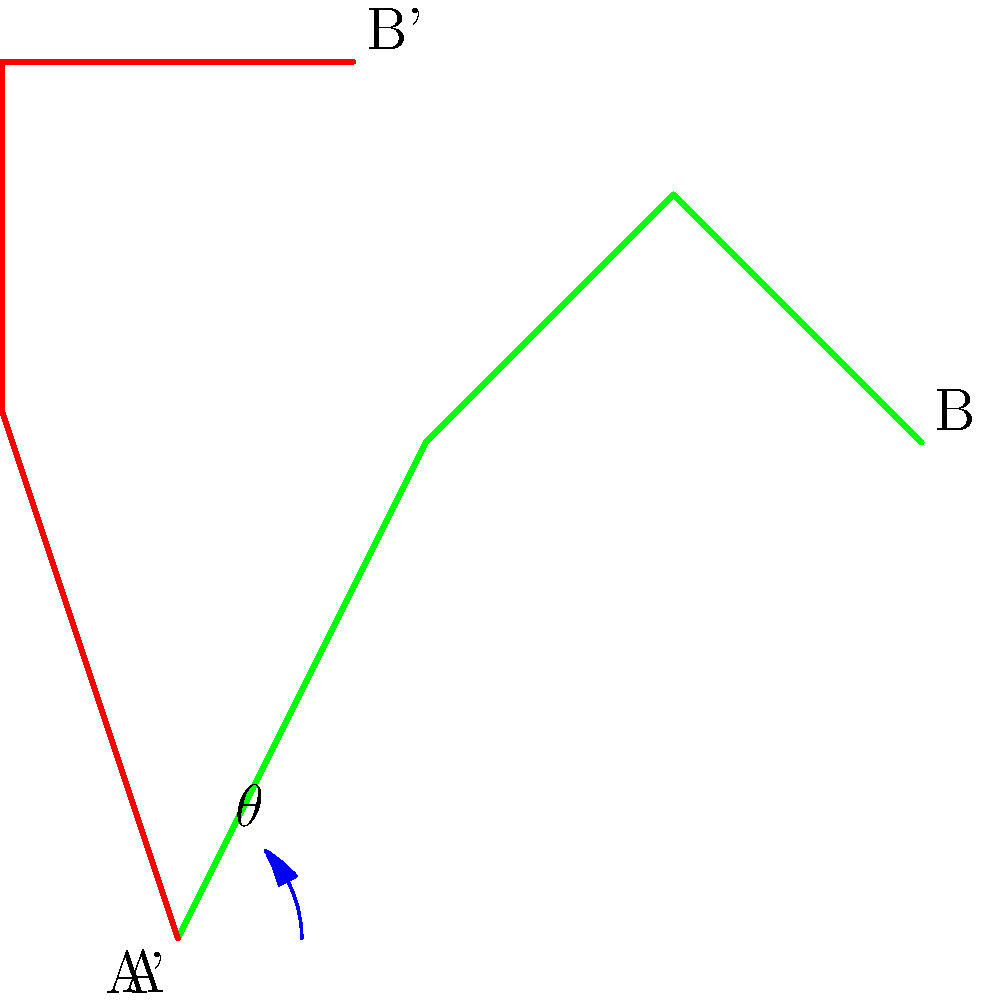As a botanist studying tree branch structures in New Zealand, you encounter two similar branch patterns from native trees. The green branch structure represents the original position, while the red branch structure shows a rotated version. What is the angle of rotation $\theta$ needed to align the green branch structure with the red one? To determine the angle of rotation, we can follow these steps:

1. Observe that the two branch structures have the same shape but are oriented differently.

2. Notice that the rotation occurs around the origin (point A) where both structures start.

3. The angle of rotation is represented by $\theta$ in the diagram, which is the angle between the original green branch and the rotated red branch.

4. In the Asymptote code used to generate this diagram, we can see that the second branch structure (red) was created by applying a rotation of 45 degrees to the first branch structure (green):

   ```
   path branch2 = rotate(45) * branch1;
   ```

5. This rotation of 45 degrees aligns the green branch structure perfectly with the red one.

Therefore, the angle of rotation $\theta$ needed to align the green branch structure with the red one is 45 degrees.
Answer: 45° 